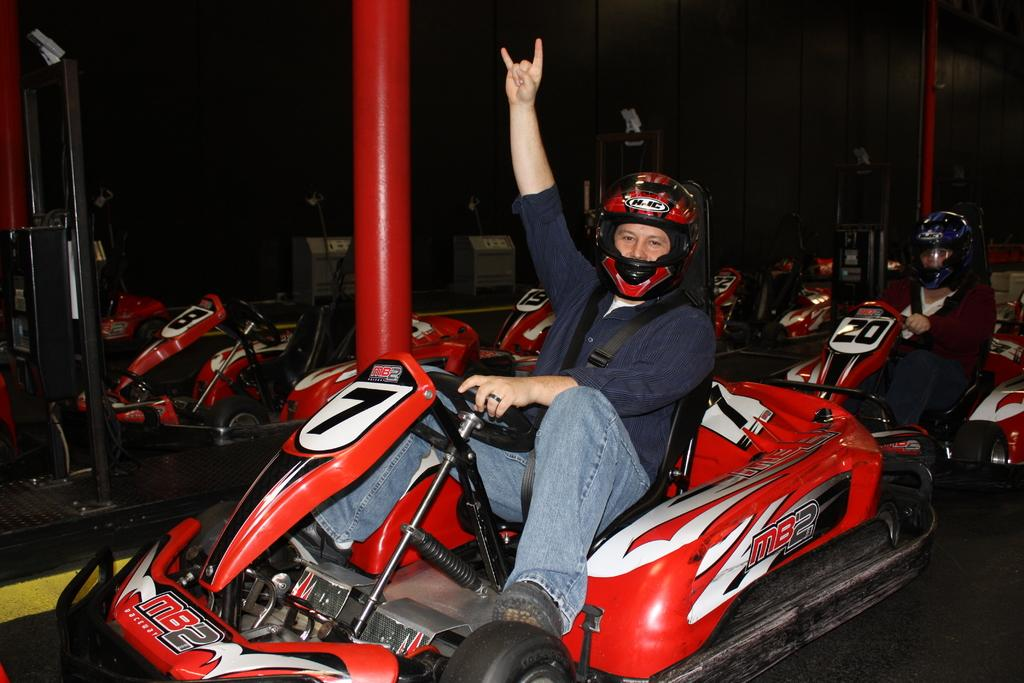How many people are in the image? There are two persons in the image. What are the persons doing in the image? The persons are riding vehicles. What else can be seen in the image besides the persons and vehicles? There are poles visible in the image. Are there any other vehicles in the image besides the ones the persons are riding? Yes, there are other vehicles in the image. Can you see any rabbits in the image? No, there are no rabbits present in the image. Is there a battle taking place in the image? No, there is no battle depicted in the image. 